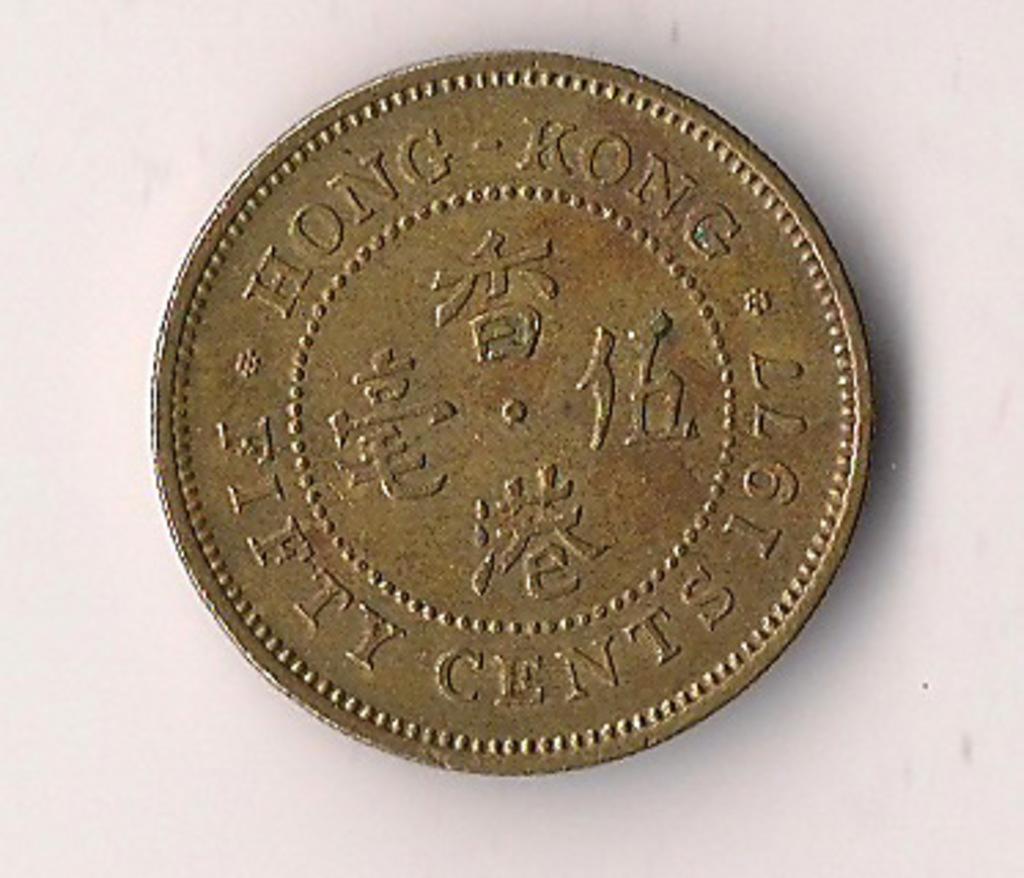Please provide a concise description of this image. In this image in the center there is one coin and in the background there is a wall. 